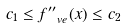<formula> <loc_0><loc_0><loc_500><loc_500>c _ { 1 } \leq f _ { \ v e } ^ { \prime \prime } ( x ) \leq c _ { 2 }</formula> 